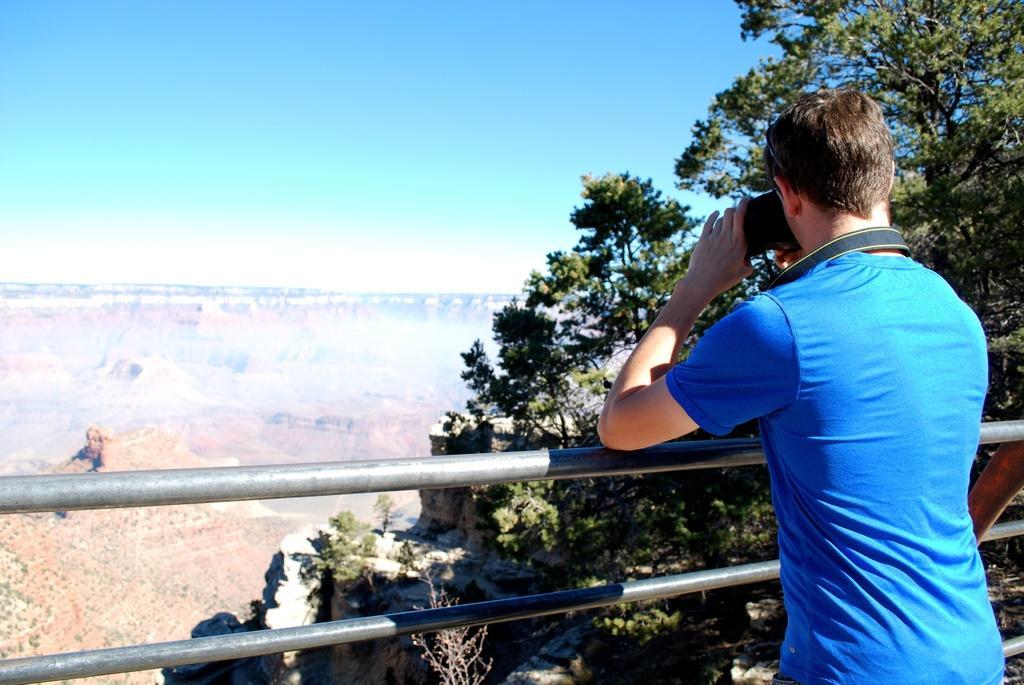Please provide a concise description of this image. In this picture I can see a man who is wearing blue color t-shirt and I see that he is holding a thing and in front of him I can see the rods. In the background I can see the trees and the sky and I can also see the land. 